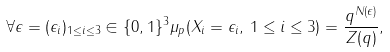<formula> <loc_0><loc_0><loc_500><loc_500>\forall \epsilon = ( \epsilon _ { i } ) _ { 1 \leq i \leq 3 } \in \{ 0 , 1 \} ^ { 3 } \mu _ { p } ( X _ { i } = \epsilon _ { i } , \, 1 \leq i \leq 3 ) = \frac { q ^ { N ( \epsilon ) } } { Z ( q ) } ,</formula> 